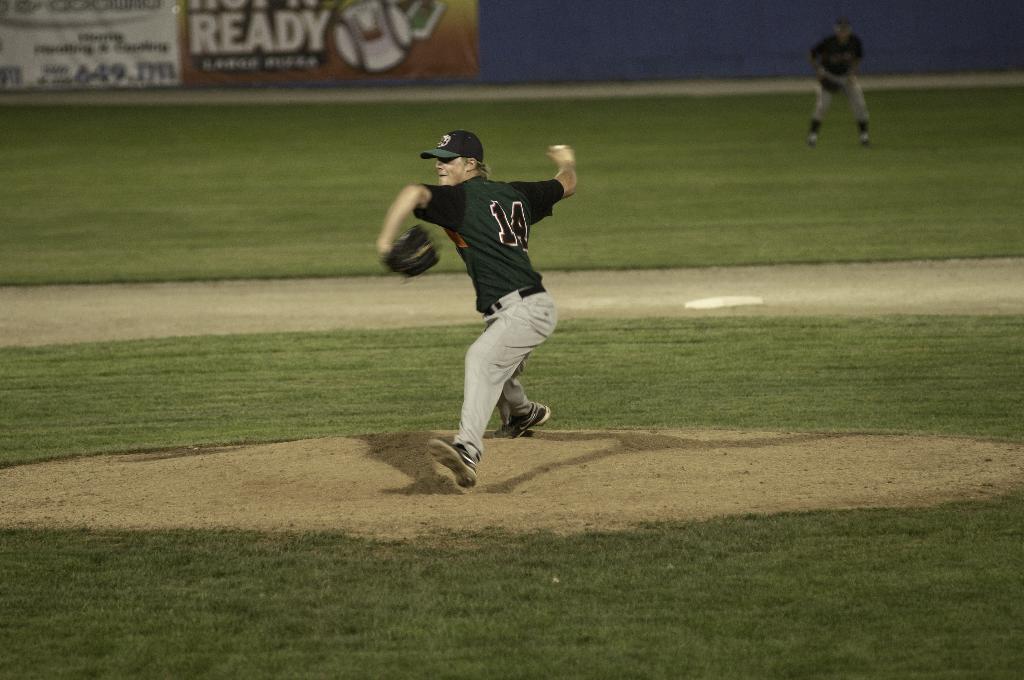What is the large word in the back on the ad?
Offer a terse response. Ready. This paly the match?
Keep it short and to the point. Unanswerable. 